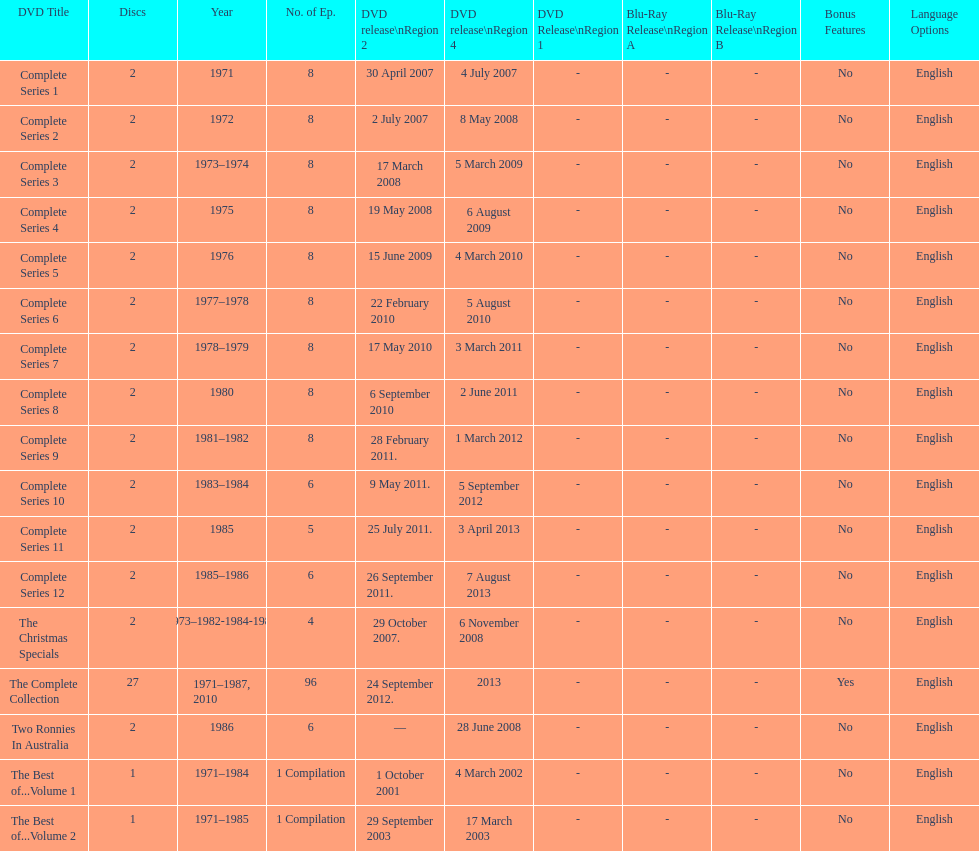Overall number of episodes unveiled in region 2 in 2007 20. 